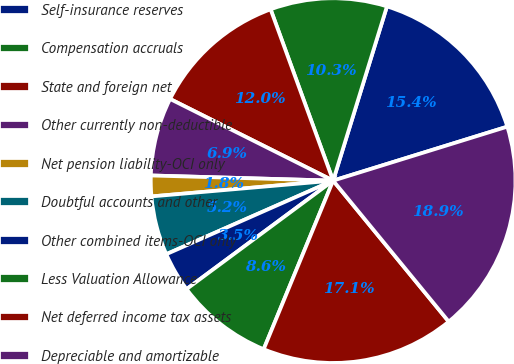Convert chart to OTSL. <chart><loc_0><loc_0><loc_500><loc_500><pie_chart><fcel>Self-insurance reserves<fcel>Compensation accruals<fcel>State and foreign net<fcel>Other currently non-deductible<fcel>Net pension liability-OCI only<fcel>Doubtful accounts and other<fcel>Other combined items-OCI only<fcel>Less Valuation Allowance<fcel>Net deferred income tax assets<fcel>Depreciable and amortizable<nl><fcel>15.45%<fcel>10.34%<fcel>12.04%<fcel>6.94%<fcel>1.83%<fcel>5.23%<fcel>3.53%<fcel>8.64%<fcel>17.15%<fcel>18.85%<nl></chart> 